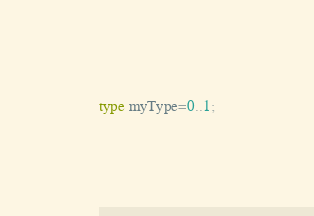<code> <loc_0><loc_0><loc_500><loc_500><_Pascal_>type myType=0..1;</code> 